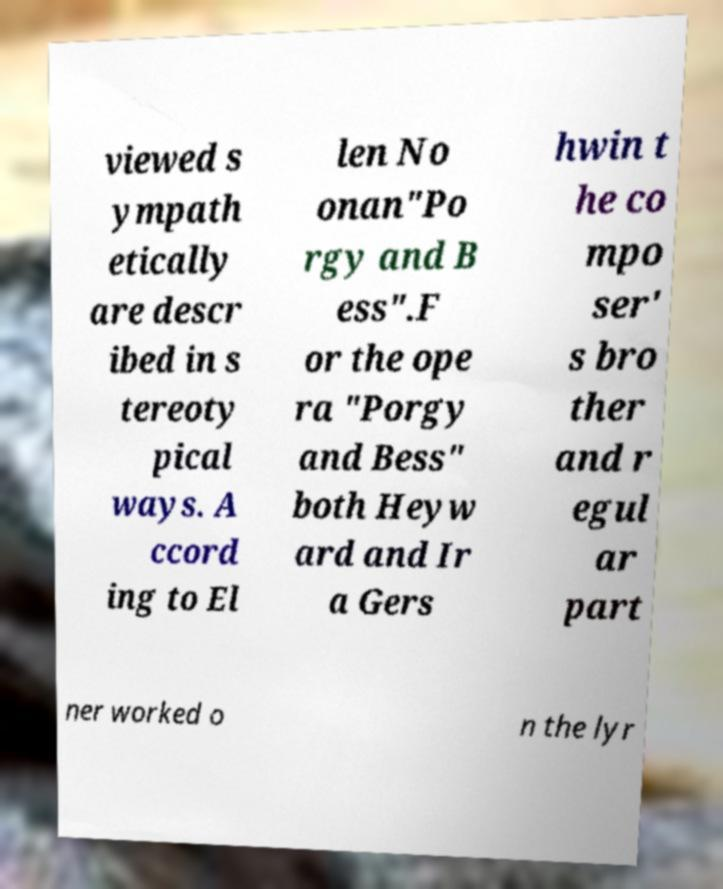For documentation purposes, I need the text within this image transcribed. Could you provide that? viewed s ympath etically are descr ibed in s tereoty pical ways. A ccord ing to El len No onan"Po rgy and B ess".F or the ope ra "Porgy and Bess" both Heyw ard and Ir a Gers hwin t he co mpo ser' s bro ther and r egul ar part ner worked o n the lyr 